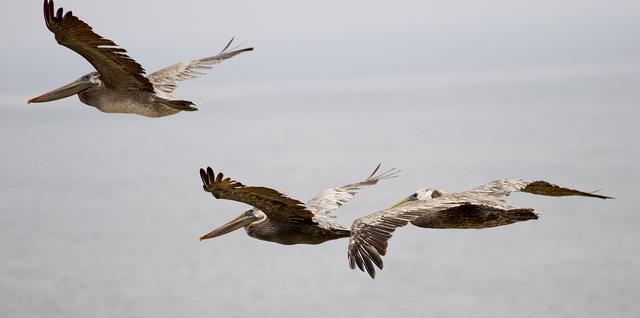How many birds are flying?
Give a very brief answer. 3. How many birds can be seen?
Give a very brief answer. 3. 